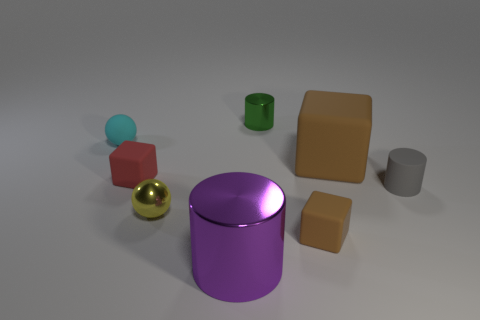What is the color of the other tiny object that is the same shape as the cyan thing? yellow 